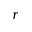Convert formula to latex. <formula><loc_0><loc_0><loc_500><loc_500>r</formula> 